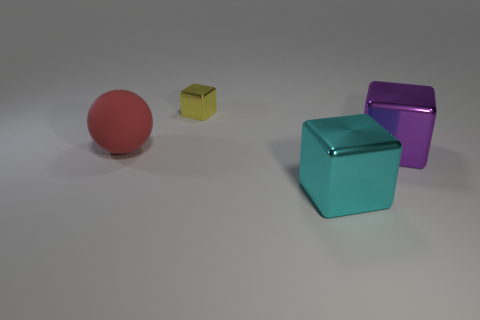Are there any other things that have the same size as the yellow thing?
Offer a terse response. No. What is the material of the other big object that is the same shape as the big purple object?
Keep it short and to the point. Metal. What is the size of the yellow metallic object?
Offer a terse response. Small. What is the material of the purple object that is the same size as the cyan object?
Make the answer very short. Metal. There is a metallic block that is behind the big object that is to the left of the small block; what number of balls are on the left side of it?
Keep it short and to the point. 1. There is another big thing that is the same material as the large purple thing; what is its color?
Offer a very short reply. Cyan. There is a block behind the red rubber object; is its size the same as the large purple cube?
Give a very brief answer. No. What number of objects are large red rubber cubes or red rubber balls?
Make the answer very short. 1. What material is the cube behind the big thing right of the large metallic object that is in front of the big purple object?
Your answer should be compact. Metal. What material is the tiny yellow block behind the big purple metallic object?
Your response must be concise. Metal. 